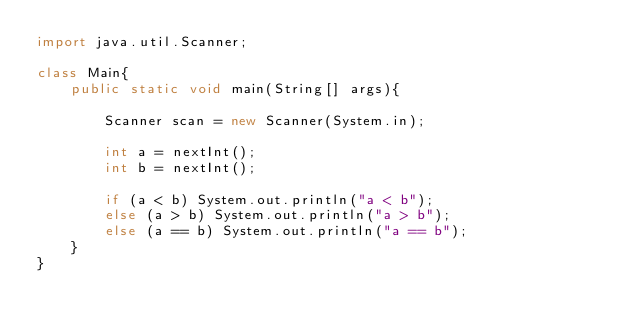<code> <loc_0><loc_0><loc_500><loc_500><_Java_>import java.util.Scanner;

class Main{
	public static void main(String[] args){
		
		Scanner scan = new Scanner(System.in);
		
		int a = nextInt();
		int b = nextInt();
		
		if (a < b) System.out.println("a < b");
		else (a > b) System.out.println("a > b");
		else (a == b) System.out.println("a == b");
	}
}</code> 